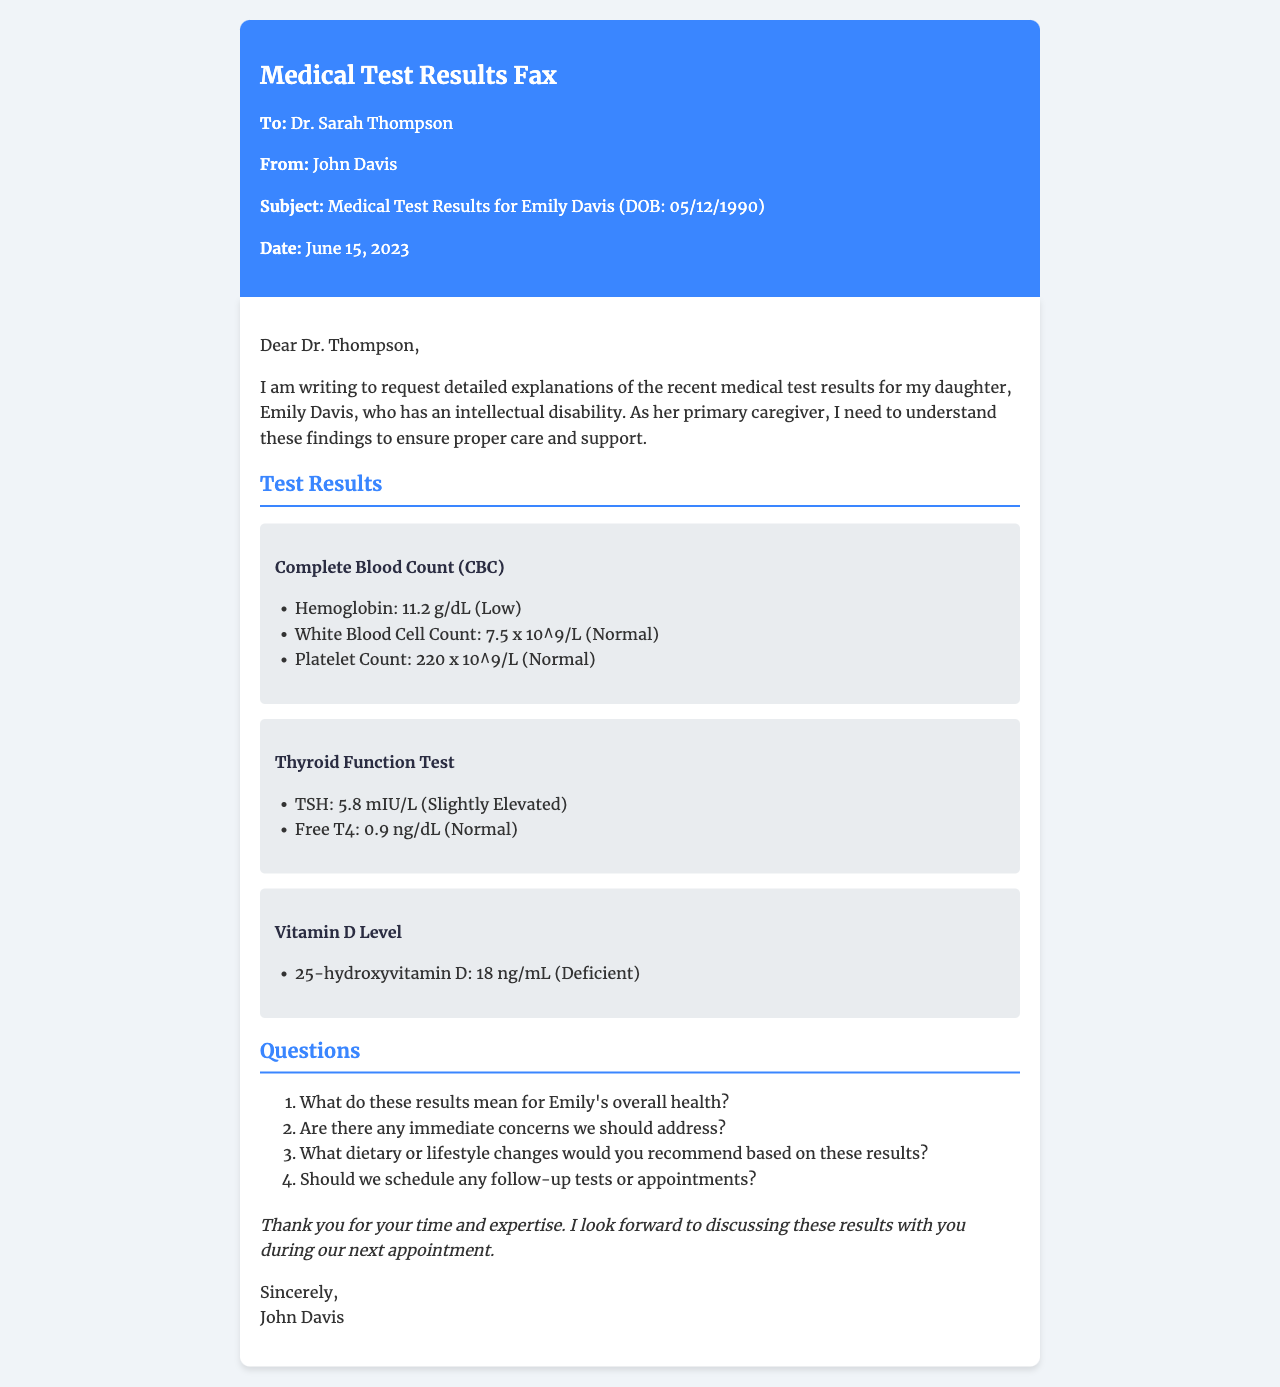What is Emily's date of birth? Emily's date of birth is stated in the document, which is 05/12/1990.
Answer: 05/12/1990 What is the hemoglobin level in the CBC test? The document specifies that the hemoglobin level in the CBC test is 11.2 g/dL, which is noted as low.
Answer: 11.2 g/dL What does the TSH level indicate in the thyroid function test? The TSH level of 5.8 mIU/L in the thyroid function test is noted as slightly elevated, indicating a potential concern.
Answer: Slightly Elevated What is the vitamin D level recorded? The document states that the 25-hydroxyvitamin D level is 18 ng/mL, which is described as deficient.
Answer: 18 ng/mL What recommendation is implied regarding Emily's vitamin D deficiency? Given the deficiency in her vitamin D level, the implication is that dietary or lifestyle changes should be considered to improve her health.
Answer: Dietary or lifestyle changes Who is the recipient of the fax? The document clearly states that the recipient of the fax is Dr. Sarah Thompson.
Answer: Dr. Sarah Thompson How many total test results are presented in the document? The document presents three distinct test results: CBC, thyroid function, and vitamin D level.
Answer: Three What is the purpose of this fax? The purpose of the fax is to request detailed explanations of the medical test results for Emily Davis.
Answer: Request for explanations 